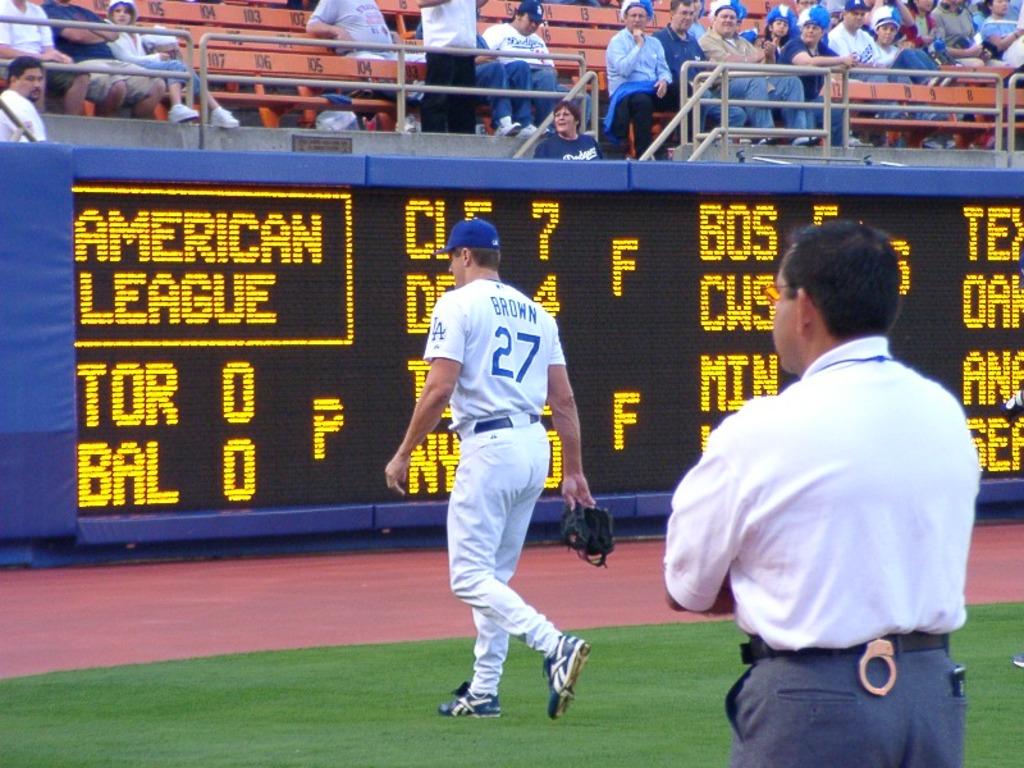What player wears number 27?
Make the answer very short. Brown. 